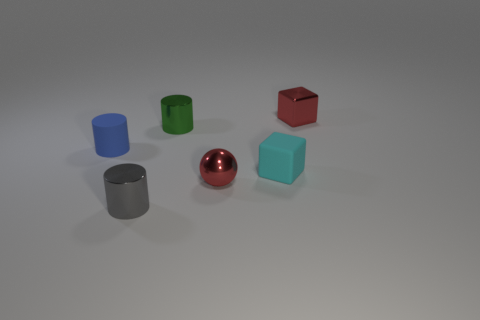How many shiny things are tiny green cylinders or tiny cubes?
Give a very brief answer. 2. What material is the tiny cylinder that is behind the tiny cyan block and to the right of the blue matte cylinder?
Provide a short and direct response. Metal. There is a small red object that is right of the block that is on the left side of the red block; is there a cyan cube that is on the right side of it?
Your response must be concise. No. Is there any other thing that is the same material as the tiny red ball?
Offer a very short reply. Yes. There is a small green object that is the same material as the tiny red cube; what is its shape?
Offer a terse response. Cylinder. Are there fewer rubber objects that are on the left side of the tiny red shiny sphere than green metal cylinders to the left of the gray thing?
Provide a succinct answer. No. How many tiny things are either red metallic things or gray cylinders?
Offer a very short reply. 3. Do the red shiny object that is behind the blue rubber cylinder and the tiny cyan thing to the right of the tiny gray cylinder have the same shape?
Your answer should be compact. Yes. There is a red metallic object that is left of the red shiny object behind the small rubber thing that is right of the green metal thing; what is its size?
Provide a succinct answer. Small. There is a rubber thing that is on the left side of the green metal object; what is its size?
Your answer should be very brief. Small. 